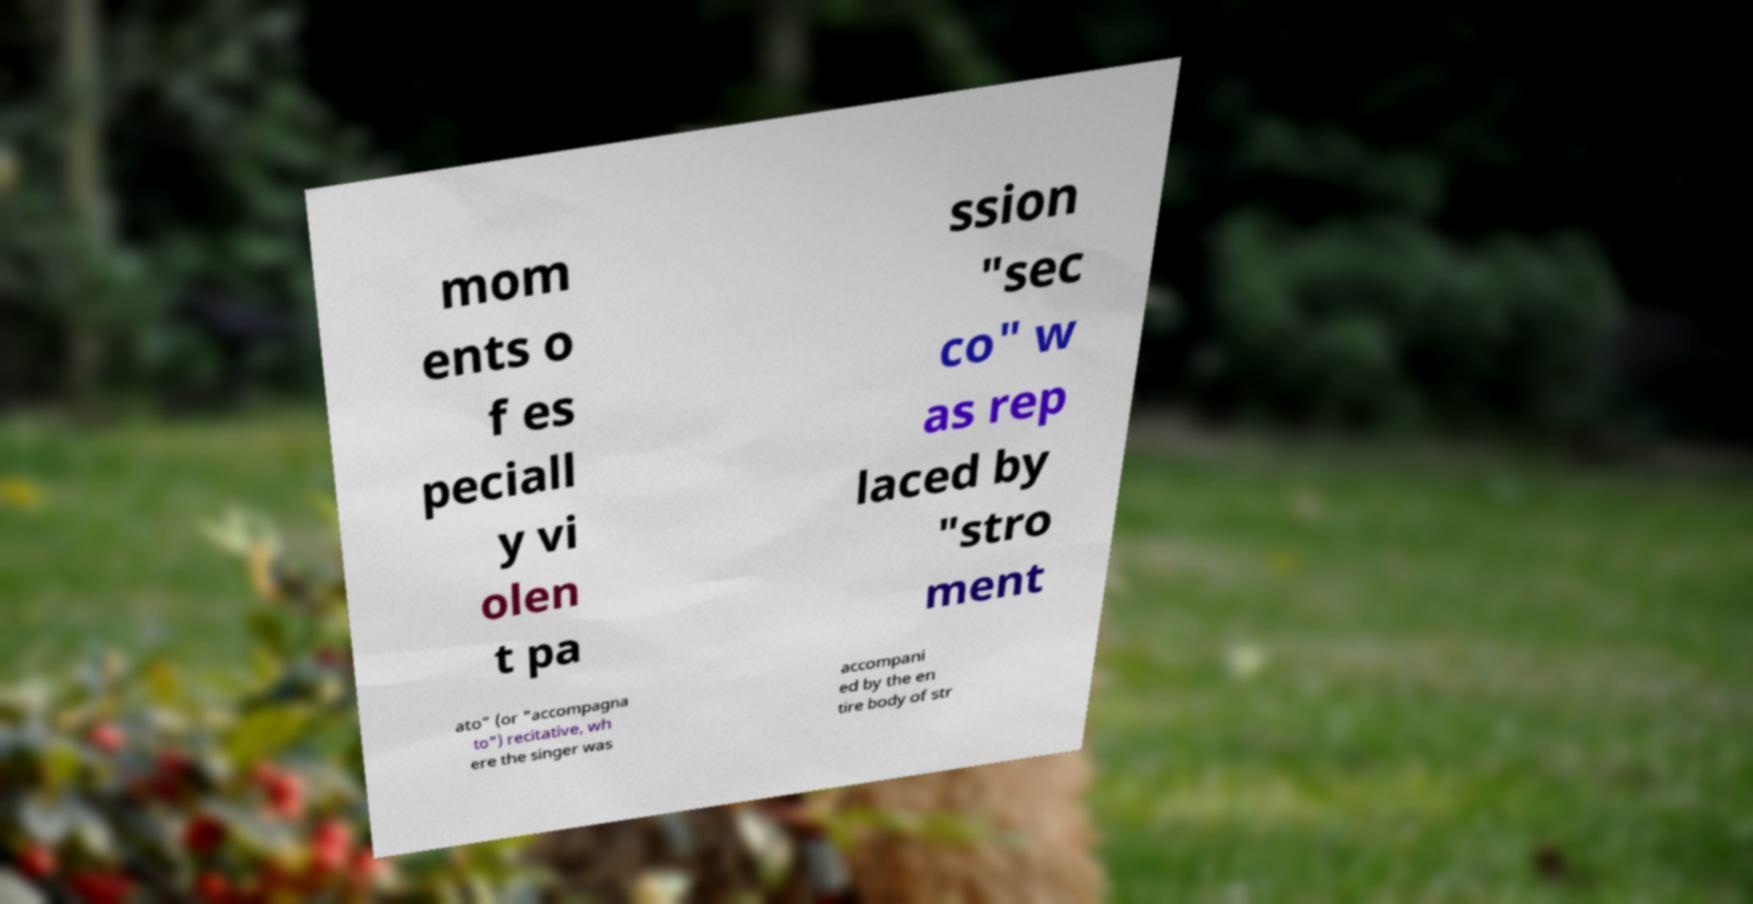Can you accurately transcribe the text from the provided image for me? mom ents o f es peciall y vi olen t pa ssion "sec co" w as rep laced by "stro ment ato" (or "accompagna to") recitative, wh ere the singer was accompani ed by the en tire body of str 